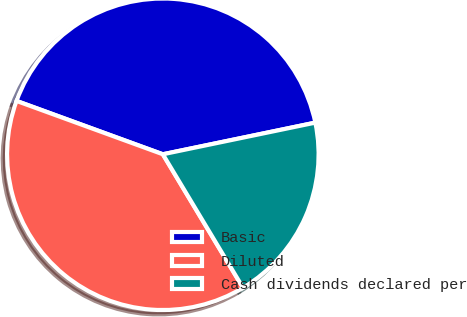Convert chart to OTSL. <chart><loc_0><loc_0><loc_500><loc_500><pie_chart><fcel>Basic<fcel>Diluted<fcel>Cash dividends declared per<nl><fcel>41.18%<fcel>39.17%<fcel>19.65%<nl></chart> 